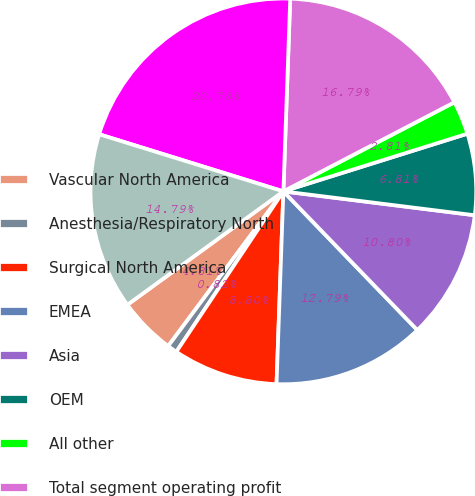Convert chart to OTSL. <chart><loc_0><loc_0><loc_500><loc_500><pie_chart><fcel>Vascular North America<fcel>Anesthesia/Respiratory North<fcel>Surgical North America<fcel>EMEA<fcel>Asia<fcel>OEM<fcel>All other<fcel>Total segment operating profit<fcel>Unallocated expenses (2)<fcel>Income from continuing<nl><fcel>4.81%<fcel>0.82%<fcel>8.8%<fcel>12.79%<fcel>10.8%<fcel>6.81%<fcel>2.81%<fcel>16.79%<fcel>20.78%<fcel>14.79%<nl></chart> 